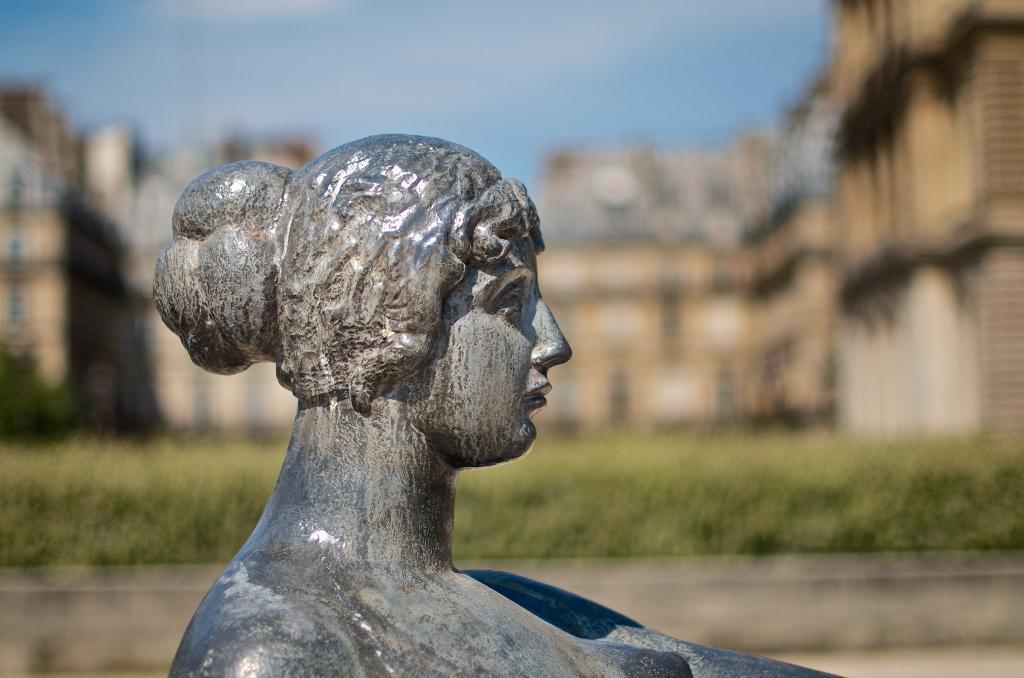How would you summarize this image in a sentence or two? In this image, we can see the statue of a lady and behind the statue there are some buildings and there is also some grass and there is a sky which is blue in color. 